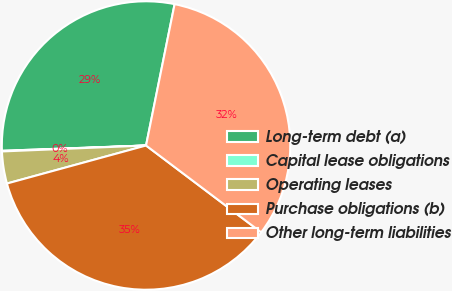Convert chart to OTSL. <chart><loc_0><loc_0><loc_500><loc_500><pie_chart><fcel>Long-term debt (a)<fcel>Capital lease obligations<fcel>Operating leases<fcel>Purchase obligations (b)<fcel>Other long-term liabilities<nl><fcel>28.76%<fcel>0.07%<fcel>3.59%<fcel>35.47%<fcel>32.11%<nl></chart> 